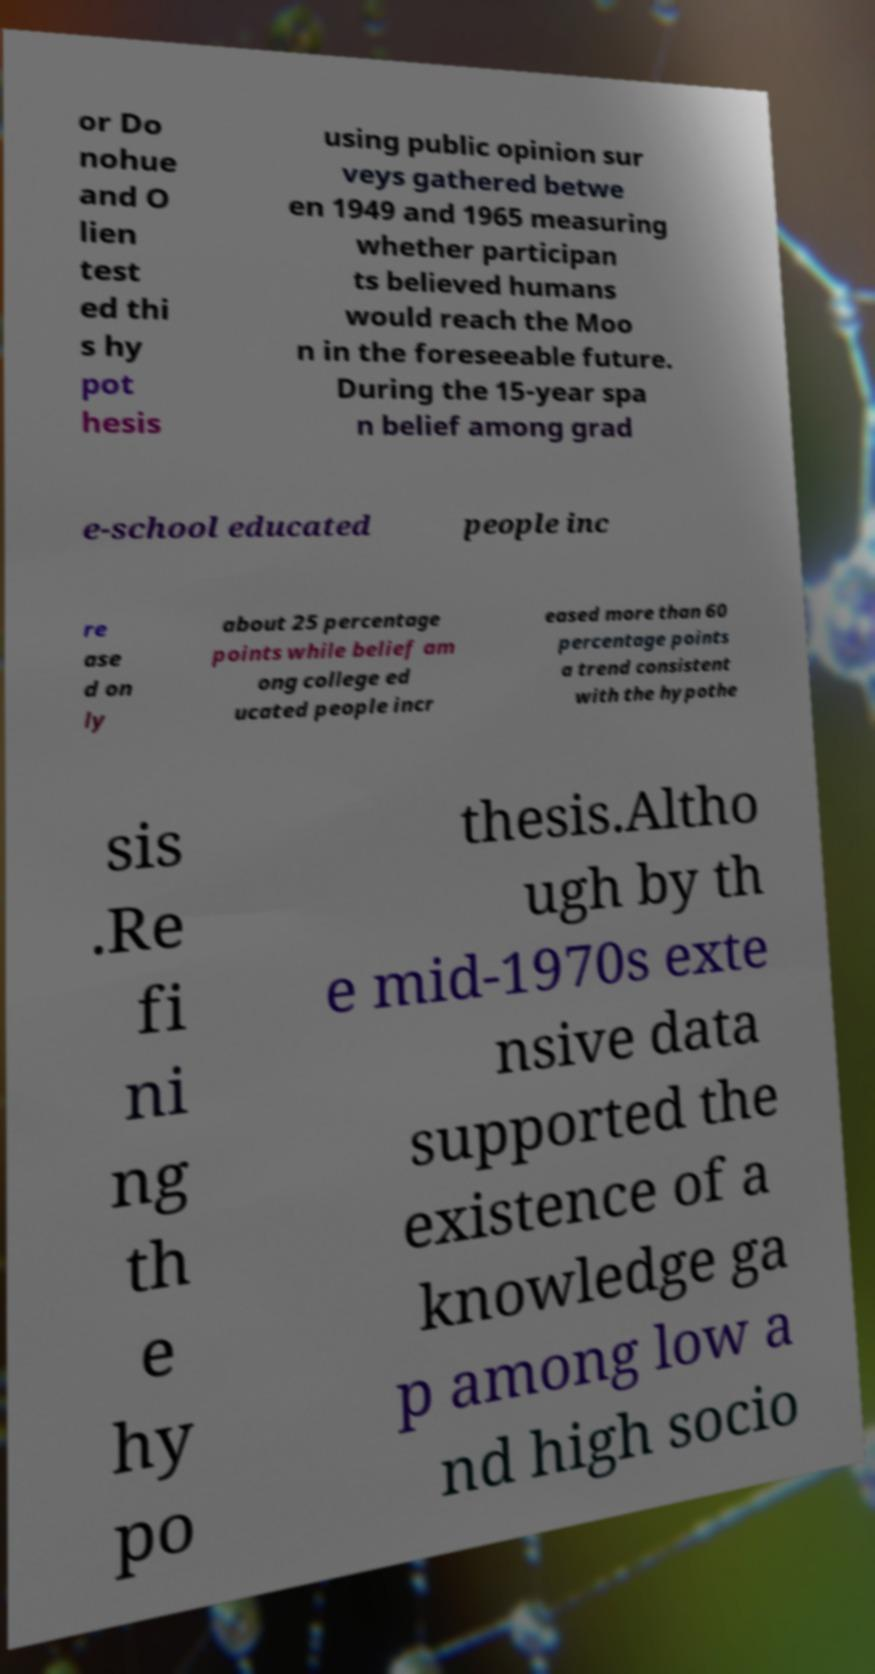Can you read and provide the text displayed in the image?This photo seems to have some interesting text. Can you extract and type it out for me? or Do nohue and O lien test ed thi s hy pot hesis using public opinion sur veys gathered betwe en 1949 and 1965 measuring whether participan ts believed humans would reach the Moo n in the foreseeable future. During the 15-year spa n belief among grad e-school educated people inc re ase d on ly about 25 percentage points while belief am ong college ed ucated people incr eased more than 60 percentage points a trend consistent with the hypothe sis .Re fi ni ng th e hy po thesis.Altho ugh by th e mid-1970s exte nsive data supported the existence of a knowledge ga p among low a nd high socio 